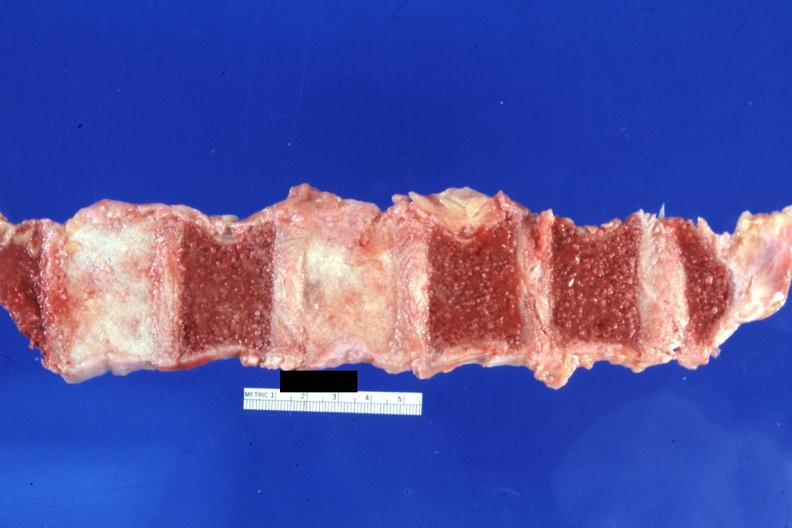what is present?
Answer the question using a single word or phrase. Joints 